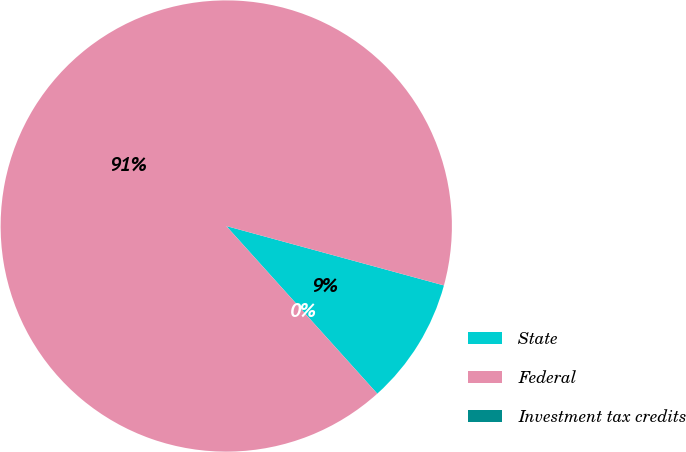Convert chart. <chart><loc_0><loc_0><loc_500><loc_500><pie_chart><fcel>State<fcel>Federal<fcel>Investment tax credits<nl><fcel>9.09%<fcel>90.9%<fcel>0.0%<nl></chart> 